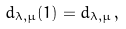<formula> <loc_0><loc_0><loc_500><loc_500>d _ { \lambda , \mu } ( 1 ) = d _ { \lambda , \mu } \, ,</formula> 